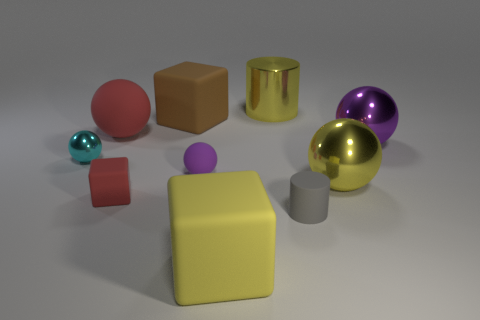Subtract all brown blocks. How many purple balls are left? 2 Subtract all yellow cubes. How many cubes are left? 2 Subtract 1 blocks. How many blocks are left? 2 Subtract all purple spheres. How many spheres are left? 3 Subtract all cylinders. How many objects are left? 8 Subtract all green blocks. Subtract all cyan balls. How many blocks are left? 3 Add 6 yellow metal cylinders. How many yellow metal cylinders exist? 7 Subtract 0 brown cylinders. How many objects are left? 10 Subtract all cyan shiny objects. Subtract all small cyan shiny objects. How many objects are left? 8 Add 6 yellow objects. How many yellow objects are left? 9 